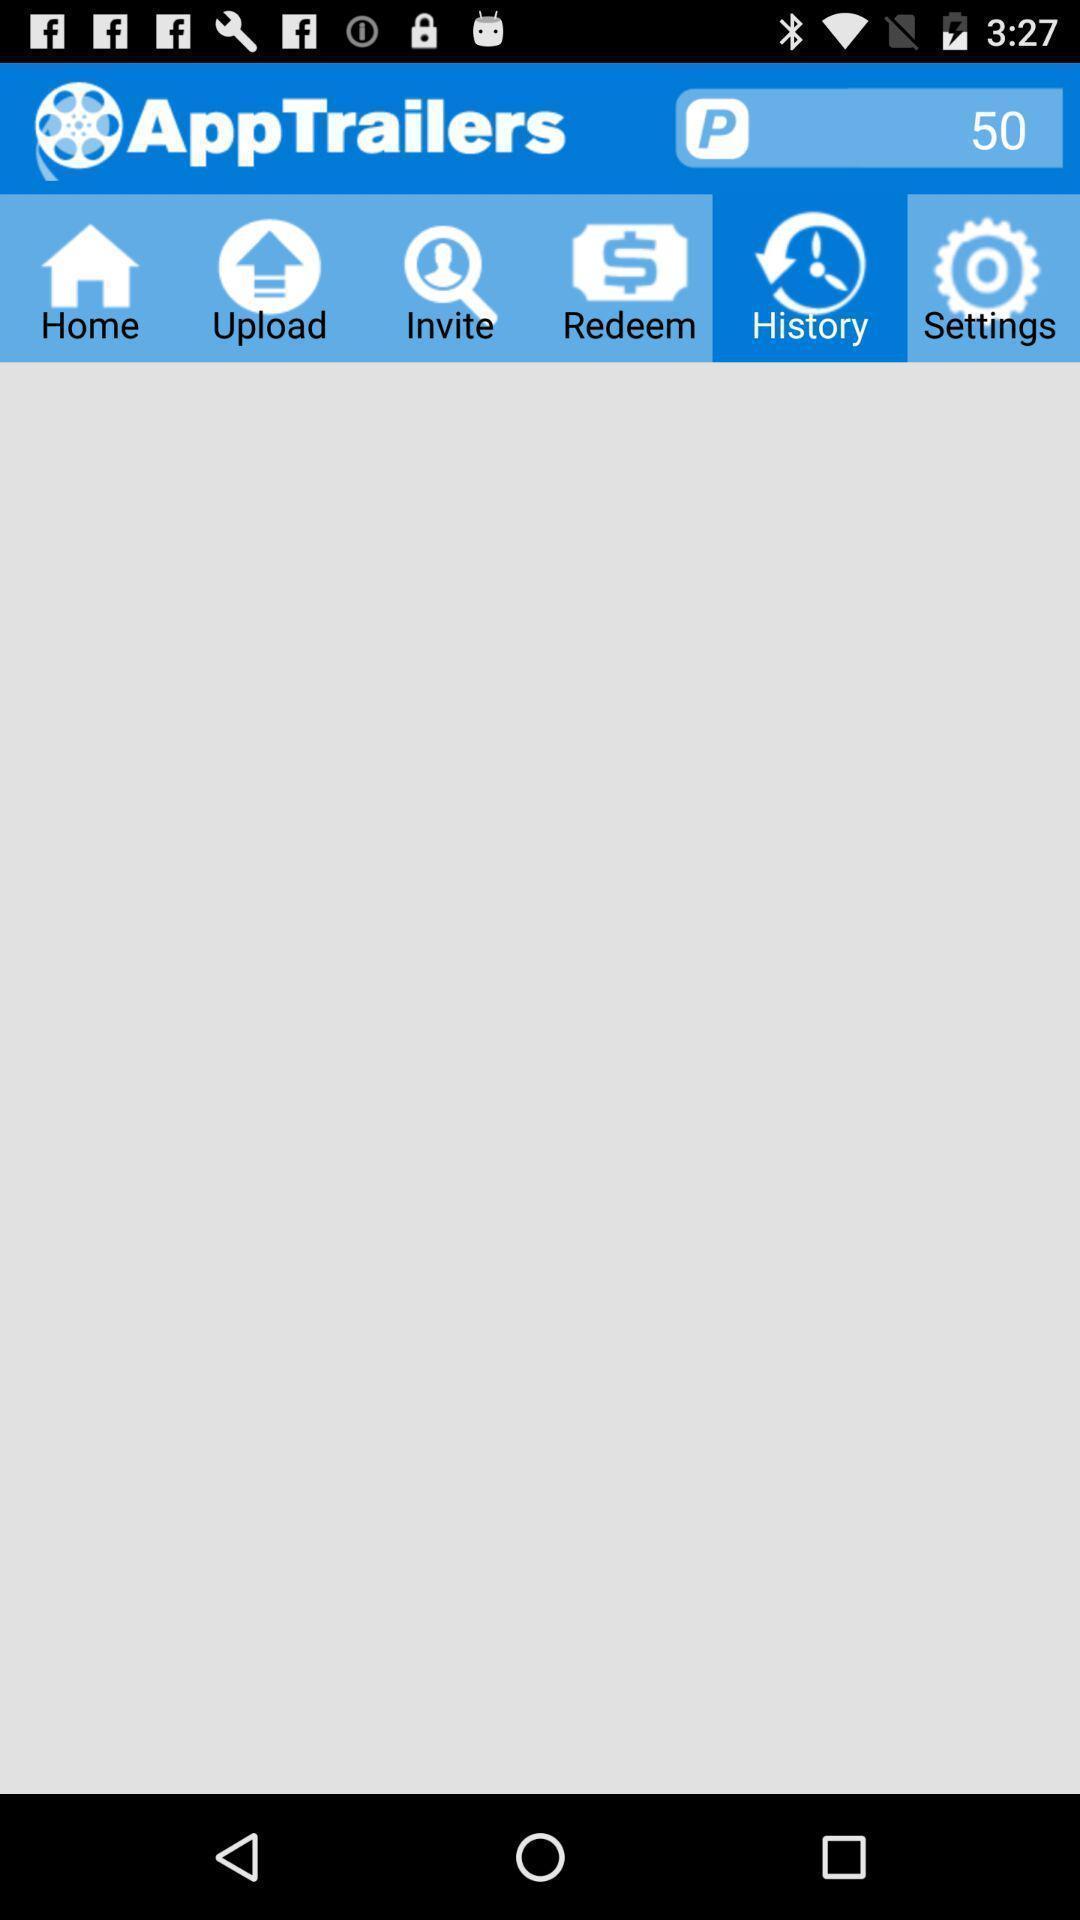Describe the key features of this screenshot. Screen showing the history page which has no content. 